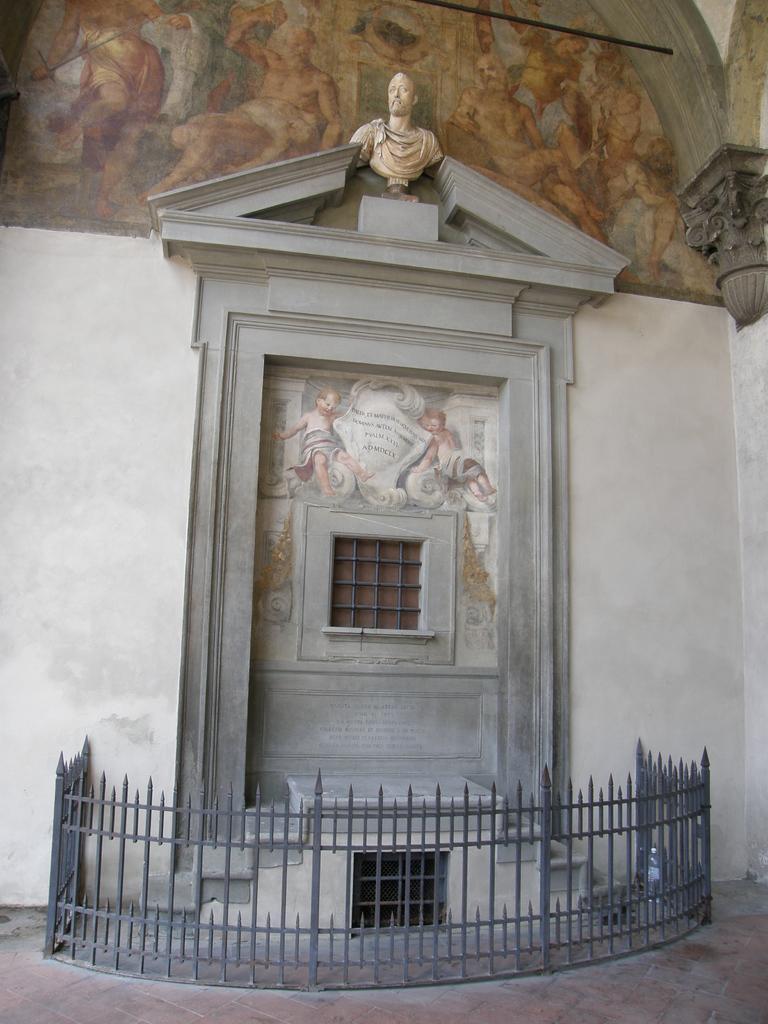Please provide a concise description of this image. In this image we can see statue, building, window, paintings on the walls and a grill. 